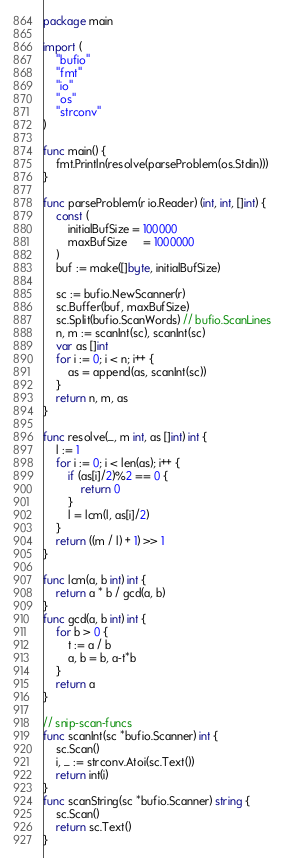<code> <loc_0><loc_0><loc_500><loc_500><_Go_>package main

import (
	"bufio"
	"fmt"
	"io"
	"os"
	"strconv"
)

func main() {
	fmt.Println(resolve(parseProblem(os.Stdin)))
}

func parseProblem(r io.Reader) (int, int, []int) {
	const (
		initialBufSize = 100000
		maxBufSize     = 1000000
	)
	buf := make([]byte, initialBufSize)

	sc := bufio.NewScanner(r)
	sc.Buffer(buf, maxBufSize)
	sc.Split(bufio.ScanWords) // bufio.ScanLines
	n, m := scanInt(sc), scanInt(sc)
	var as []int
	for i := 0; i < n; i++ {
		as = append(as, scanInt(sc))
	}
	return n, m, as
}

func resolve(_, m int, as []int) int {
	l := 1
	for i := 0; i < len(as); i++ {
		if (as[i]/2)%2 == 0 {
			return 0
		}
		l = lcm(l, as[i]/2)
	}
	return ((m / l) + 1) >> 1
}

func lcm(a, b int) int {
	return a * b / gcd(a, b)
}
func gcd(a, b int) int {
	for b > 0 {
		t := a / b
		a, b = b, a-t*b
	}
	return a
}

// snip-scan-funcs
func scanInt(sc *bufio.Scanner) int {
	sc.Scan()
	i, _ := strconv.Atoi(sc.Text())
	return int(i)
}
func scanString(sc *bufio.Scanner) string {
	sc.Scan()
	return sc.Text()
}
</code> 